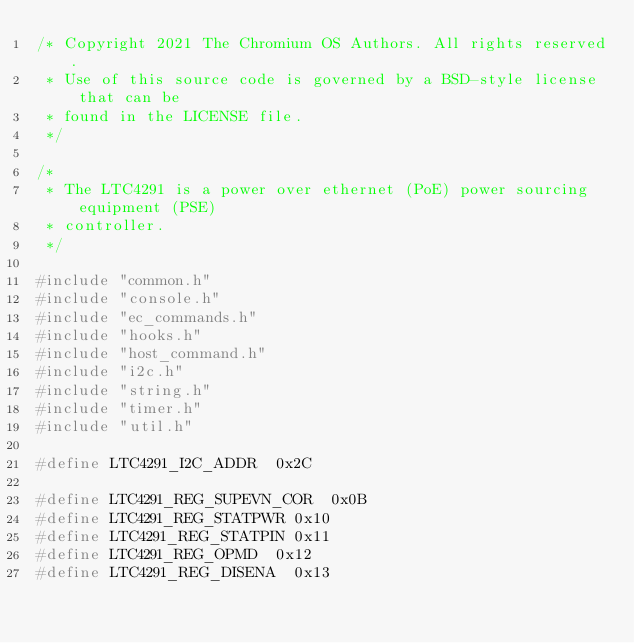<code> <loc_0><loc_0><loc_500><loc_500><_C_>/* Copyright 2021 The Chromium OS Authors. All rights reserved.
 * Use of this source code is governed by a BSD-style license that can be
 * found in the LICENSE file.
 */

/*
 * The LTC4291 is a power over ethernet (PoE) power sourcing equipment (PSE)
 * controller.
 */

#include "common.h"
#include "console.h"
#include "ec_commands.h"
#include "hooks.h"
#include "host_command.h"
#include "i2c.h"
#include "string.h"
#include "timer.h"
#include "util.h"

#define LTC4291_I2C_ADDR	0x2C

#define LTC4291_REG_SUPEVN_COR	0x0B
#define LTC4291_REG_STATPWR	0x10
#define LTC4291_REG_STATPIN	0x11
#define LTC4291_REG_OPMD	0x12
#define LTC4291_REG_DISENA	0x13</code> 